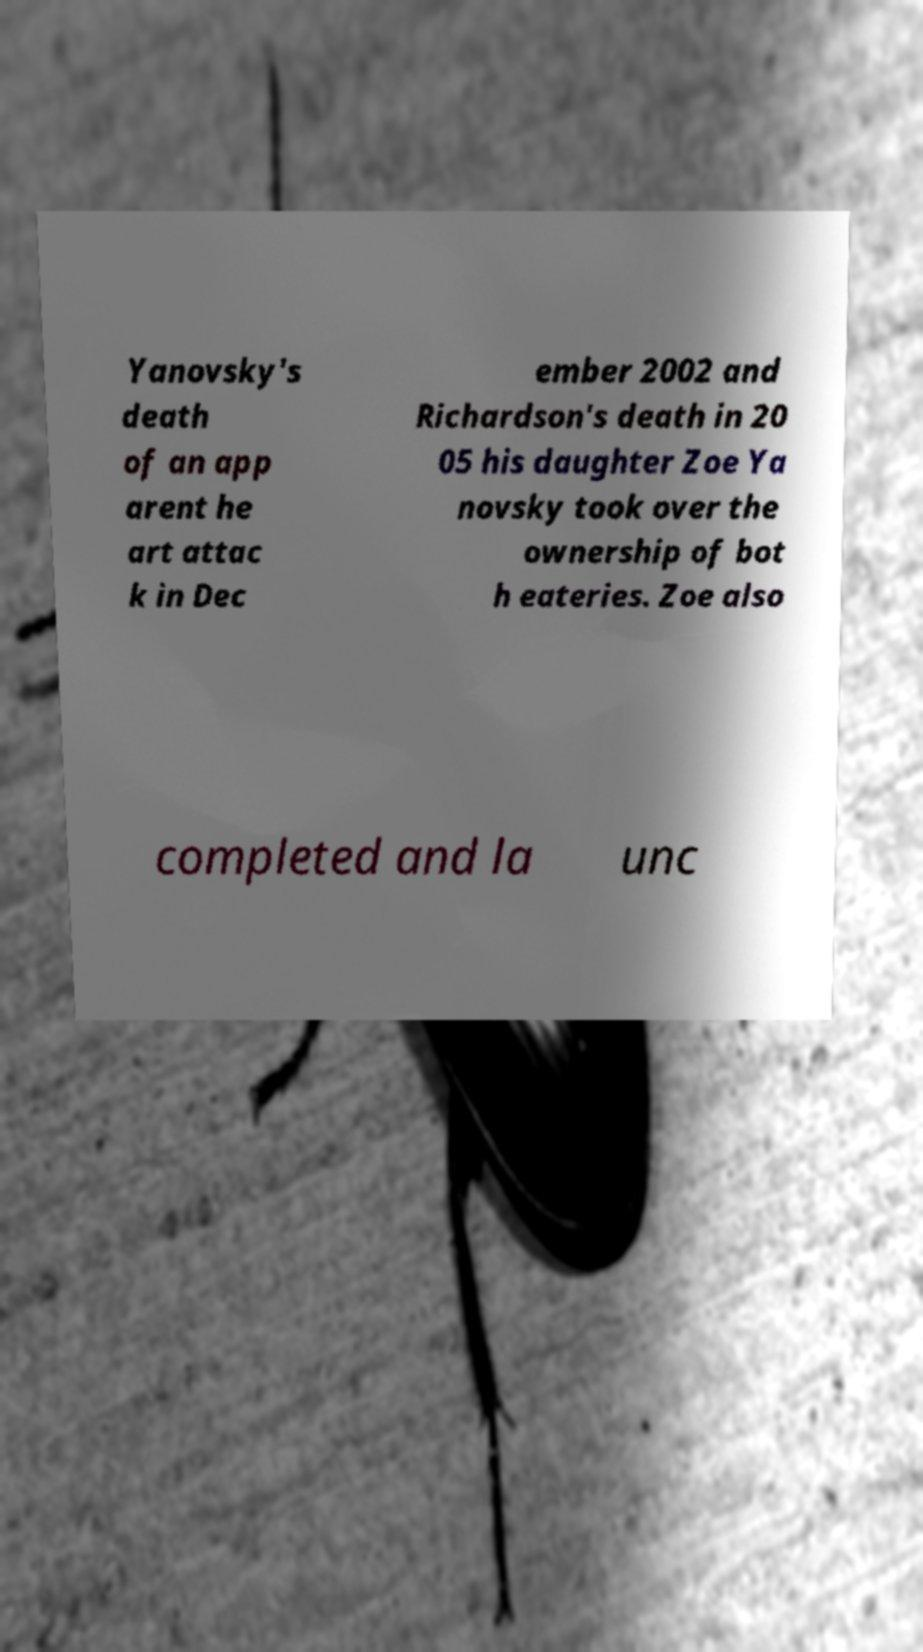For documentation purposes, I need the text within this image transcribed. Could you provide that? Yanovsky's death of an app arent he art attac k in Dec ember 2002 and Richardson's death in 20 05 his daughter Zoe Ya novsky took over the ownership of bot h eateries. Zoe also completed and la unc 